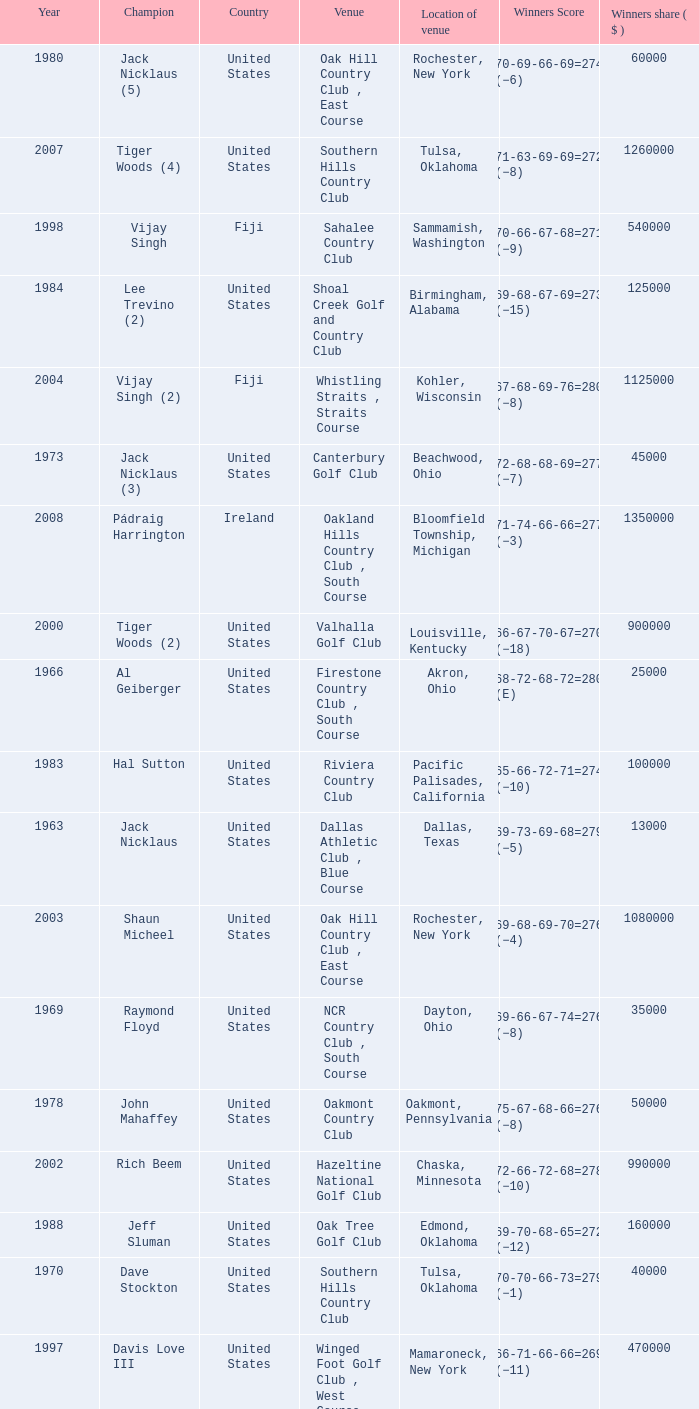Where is the Bellerive Country Club venue located? St. Louis, Missouri. 